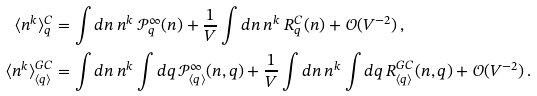Convert formula to latex. <formula><loc_0><loc_0><loc_500><loc_500>\langle n ^ { k } \rangle _ { q } ^ { C } & = \int d n \, n ^ { k } \, \mathcal { P } _ { q } ^ { \infty } ( n ) + \frac { 1 } { V } \int d n \, n ^ { k } \, R ^ { C } _ { q } ( n ) + \mathcal { O } ( V ^ { - 2 } ) \, , \\ \langle n ^ { k } \rangle _ { \langle q \rangle } ^ { G C } & = \int d n \, n ^ { k } \int d q \, \mathcal { P } _ { \langle q \rangle } ^ { \infty } ( n , q ) + \frac { 1 } { V } \int d n \, n ^ { k } \int d q \, R ^ { G C } _ { \langle q \rangle } ( n , q ) + \mathcal { O } ( V ^ { - 2 } ) \, .</formula> 